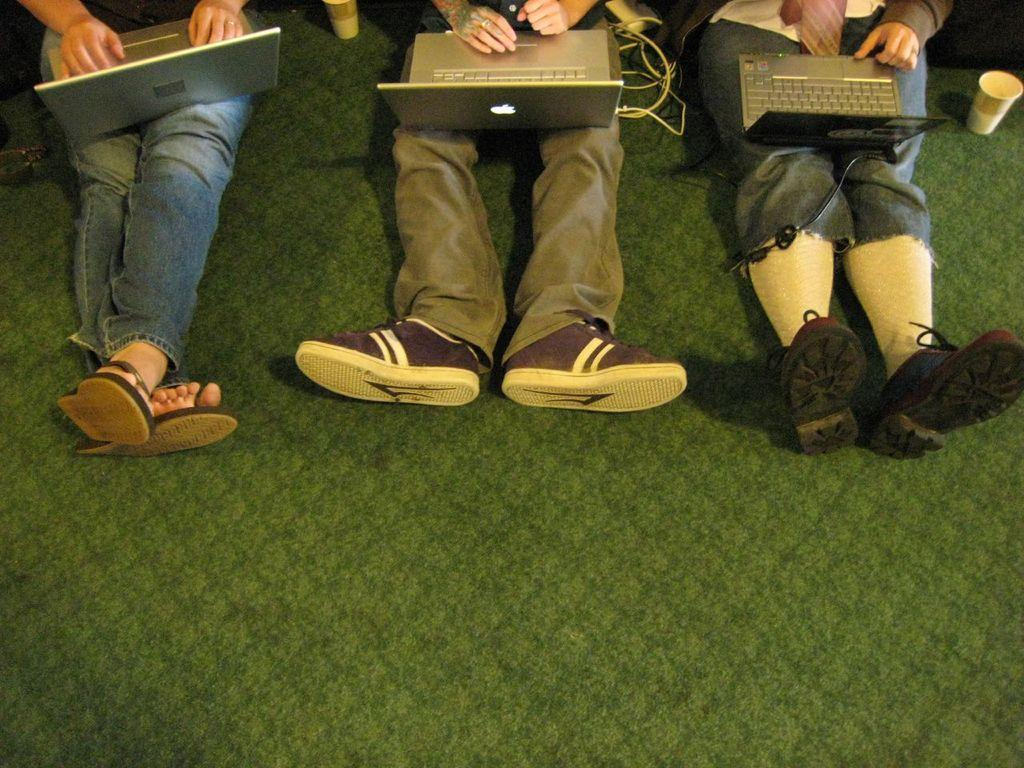How many people are in the image? There are three people in the image. What are the people doing in the image? The people are sitting on a carpet, and each person has a laptop on their lap. What objects are present in the image besides the people and laptops? There are glasses and cables visible in the image. What type of sugar is being used to power the laptops in the image? There is no sugar present in the image, and laptops are powered by electricity, not sugar. 